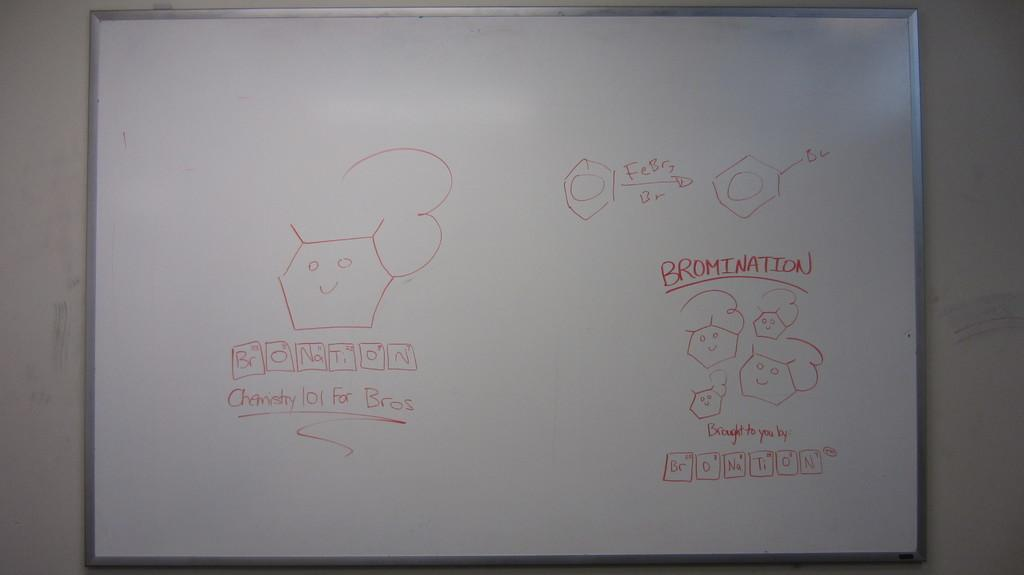<image>
Relay a brief, clear account of the picture shown. A white board has the word chemistry written in red. 